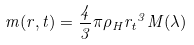<formula> <loc_0><loc_0><loc_500><loc_500>m ( r , t ) = \frac { 4 } { 3 } \pi { \rho } _ { H } { r _ { t } } ^ { 3 } M ( \lambda )</formula> 